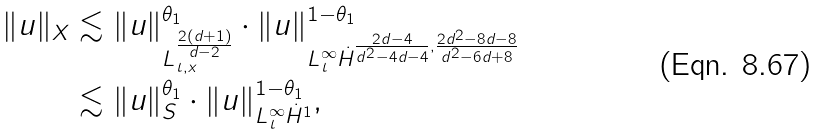<formula> <loc_0><loc_0><loc_500><loc_500>\| u \| _ { X } & \lesssim \| u \| _ { L _ { t , x } ^ { \frac { 2 ( d + 1 ) } { d - 2 } } } ^ { \theta _ { 1 } } \cdot \| u \| ^ { 1 - \theta _ { 1 } } _ { L _ { t } ^ { \infty } \dot { H } ^ { \frac { 2 d - 4 } { d ^ { 2 } - 4 d - 4 } , \frac { 2 d ^ { 2 } - 8 d - 8 } { d ^ { 2 } - 6 d + 8 } } } \\ & \lesssim \| u \| _ { S } ^ { \theta _ { 1 } } \cdot \| u \| _ { L _ { t } ^ { \infty } \dot { H } ^ { 1 } } ^ { 1 - \theta _ { 1 } } ,</formula> 